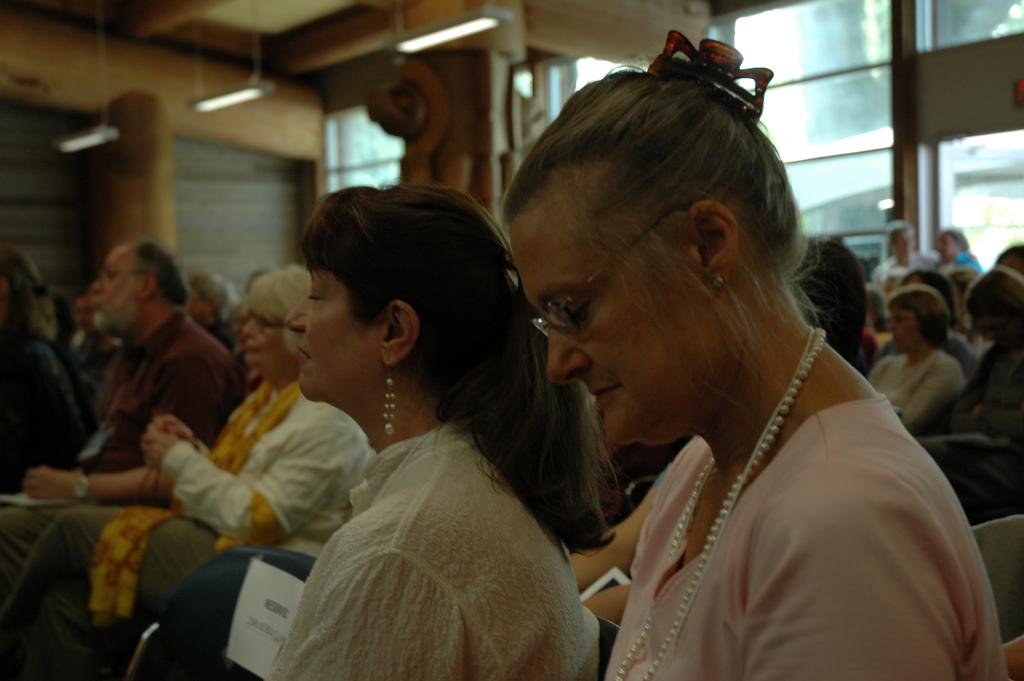What are the people in the image doing? The people in the image are sitting on chairs. What can be seen in the background of the image? There is a framed glass wall and lights visible in the background of the image. Are there any other objects present in the background of the image? Yes, there are other objects present in the background of the image. How does the earthquake affect the people sitting on chairs in the image? There is no earthquake present in the image; the people are sitting on chairs without any disturbance. 